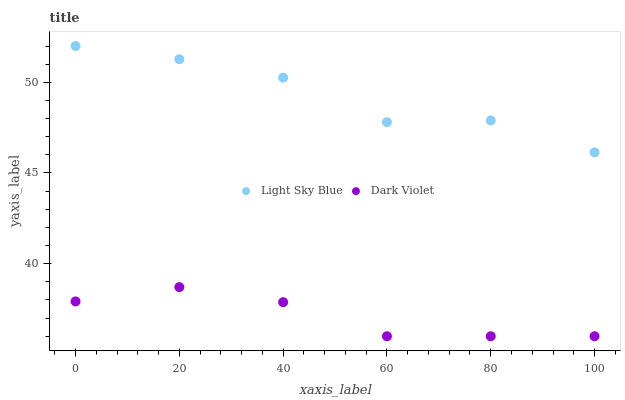Does Dark Violet have the minimum area under the curve?
Answer yes or no. Yes. Does Light Sky Blue have the maximum area under the curve?
Answer yes or no. Yes. Does Dark Violet have the maximum area under the curve?
Answer yes or no. No. Is Dark Violet the smoothest?
Answer yes or no. Yes. Is Light Sky Blue the roughest?
Answer yes or no. Yes. Is Dark Violet the roughest?
Answer yes or no. No. Does Dark Violet have the lowest value?
Answer yes or no. Yes. Does Light Sky Blue have the highest value?
Answer yes or no. Yes. Does Dark Violet have the highest value?
Answer yes or no. No. Is Dark Violet less than Light Sky Blue?
Answer yes or no. Yes. Is Light Sky Blue greater than Dark Violet?
Answer yes or no. Yes. Does Dark Violet intersect Light Sky Blue?
Answer yes or no. No. 